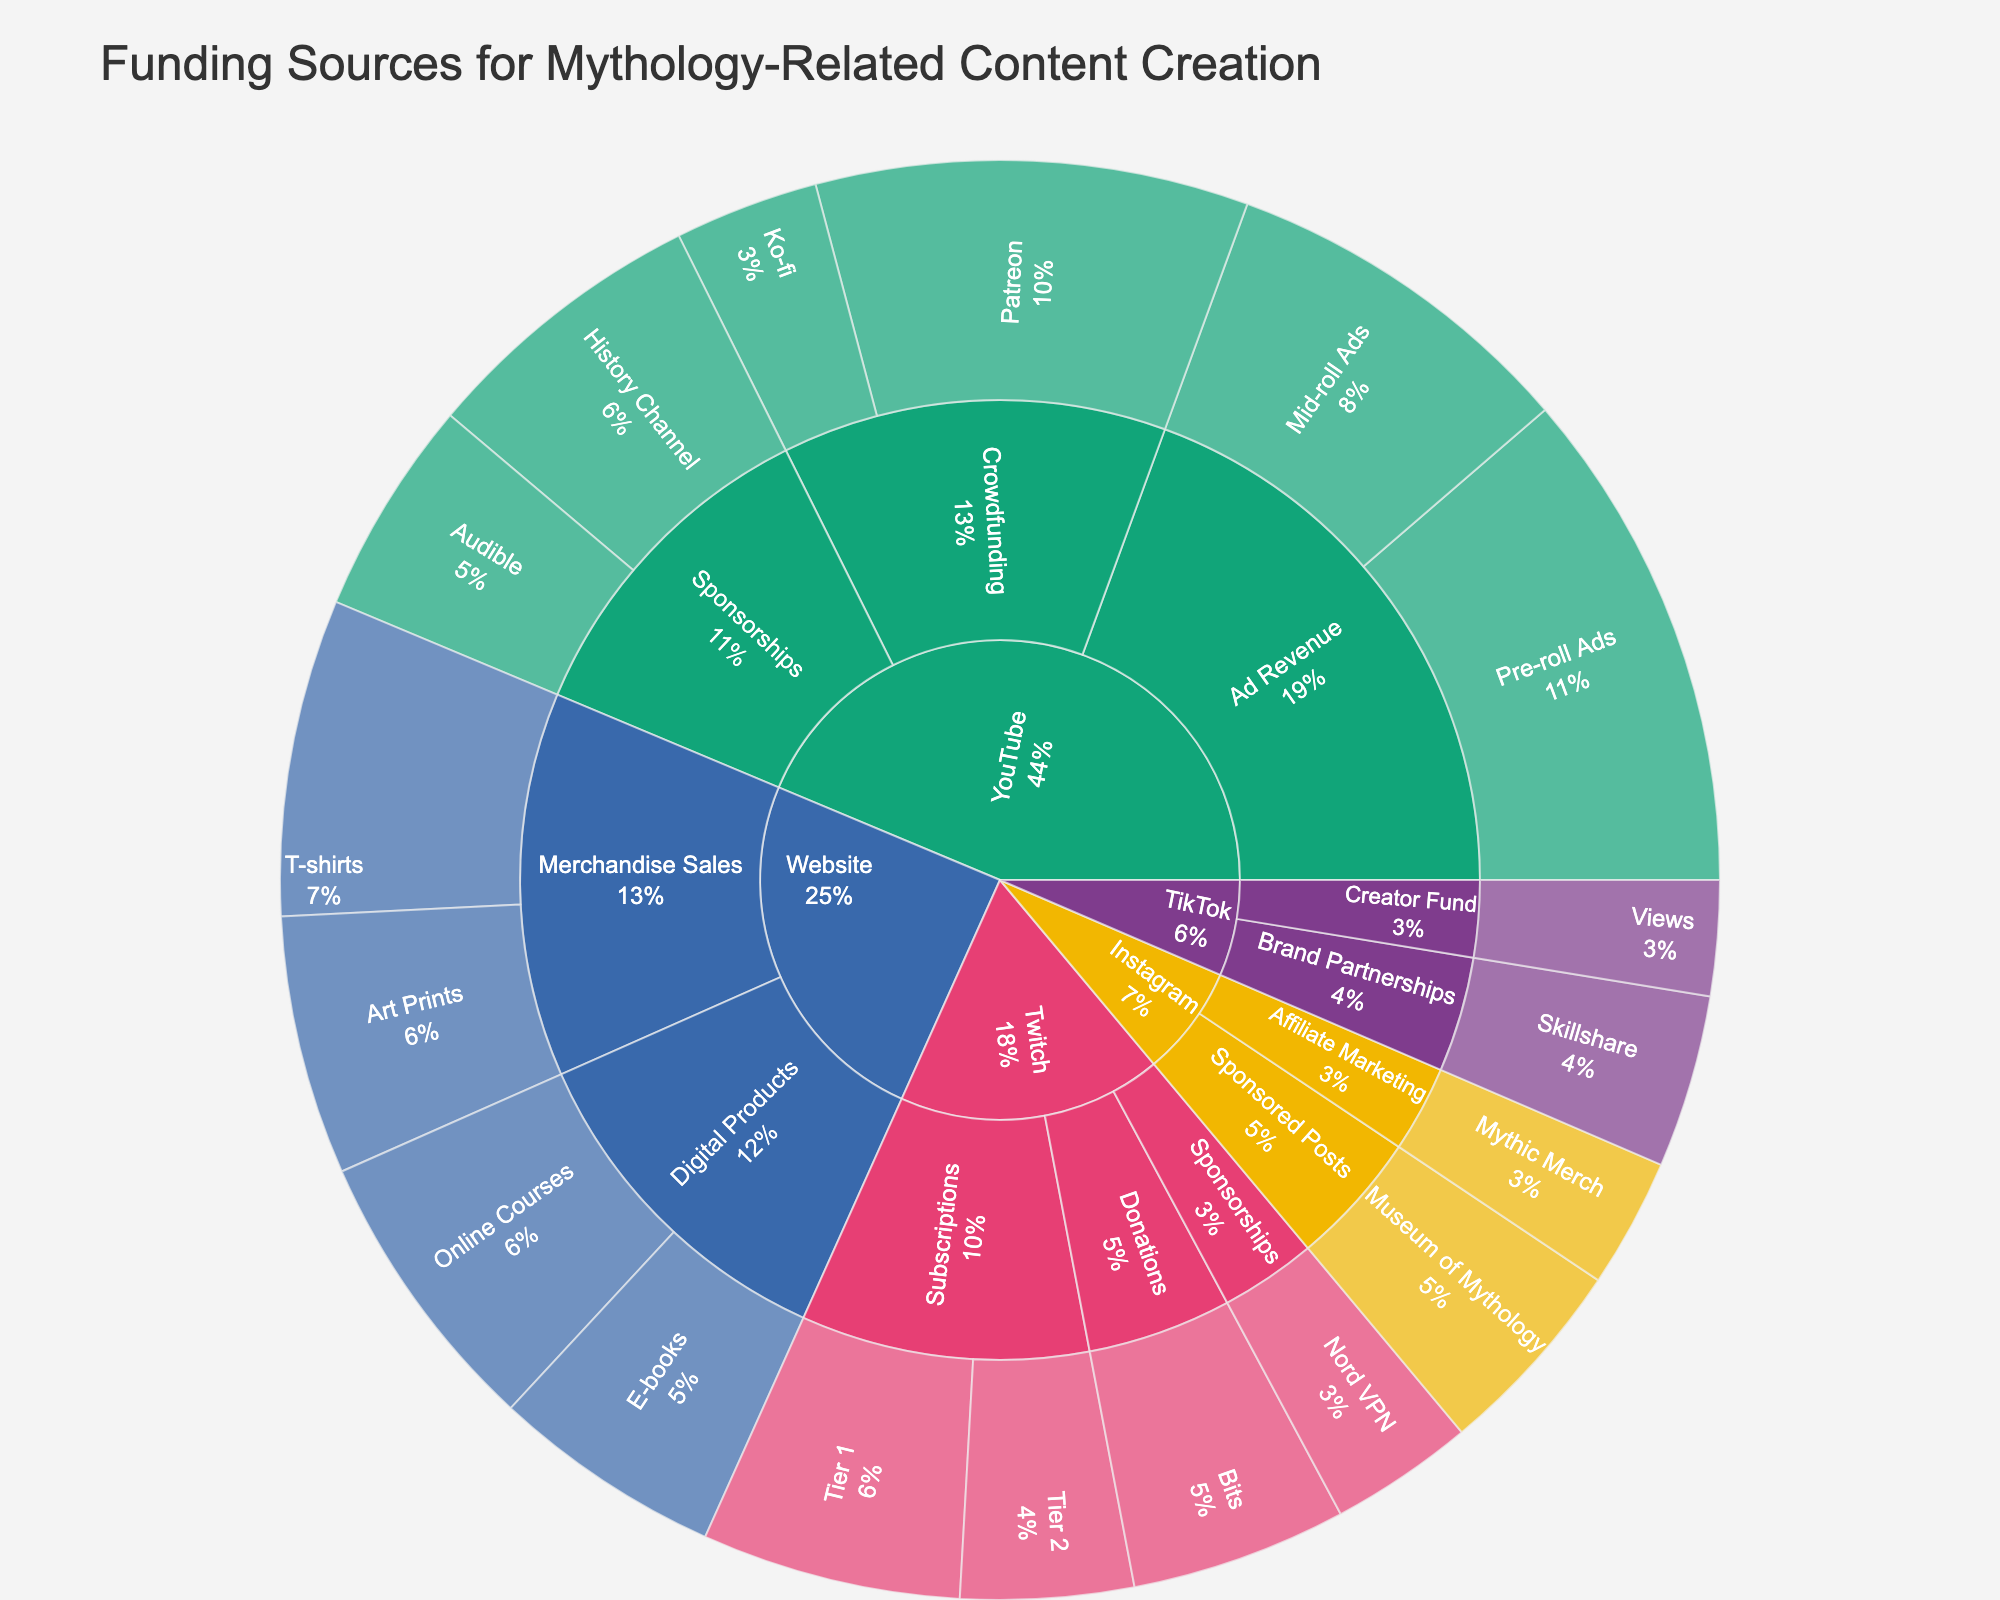What's the title of the Sunburst Plot? The title of the Sunburst Plot is located at the top of the figure, usually written in a larger font than the rest of the text on the plot.
Answer: Funding Sources for Mythology-Related Content Creation Which platform has the highest total funding? To find the platform with the highest total funding, compare the sum of values for each platform segment. YouTube has the largest segments and hence the highest total value, summing up all the YouTube sections.
Answer: YouTube What's the largest revenue source on YouTube? On YouTube, the largest revenue source can be identified by comparing the sizes of segments under YouTube. "Ad Revenue" is the largest, with segments for Pre-roll Ads (35) and Mid-roll Ads (25), totaling 60.
Answer: Ad Revenue What’s the combined value of Crowdfunding sources on YouTube? Add the values for Patreon (30) and Ko-fi (10) under YouTube’s Crowdfunding section. The combined value is 30 + 10 = 40.
Answer: 40 Which platform has sponsorship from Nord VPN? Look for the segment associated with Nord VPN. It is listed under Twitch in the Sponsorships section.
Answer: Twitch How much funding does TikTok get from Brand Partnerships? Check the segment under TikTok labeled "Brand Partnerships" and find the value associated with Skillshare, which is 12.
Answer: 12 Among Twitch and TikTok, which has higher funding from subscriptions, donations, and creator fund respectively combined? Add the values for subscriptions and donations for Twitch (Tier 1: 18, Tier 2: 12, Bits: 15) giving (18+12+15)=45 and add the creator fund for TikTok (Views: 8), so Twitch has higher combined funding.
Answer: Twitch What’s the total funding from YouTube’s Sponsorships? Add History Channel (20) and Audible (15) values under YouTube’s Sponsorships section. The total value is 20 + 15 = 35.
Answer: 35 Which platform has the least number of funding sources mentioned in the plot? Count the distinct funding sources for each platform. TikTok has only two funding sources—Creator Fund and Brand Partnerships—making it the platform with the least number of funding sources listed.
Answer: TikTok How does funding from donations on Twitch compare to ad revenue on YouTube? Compare the sum of donations on Twitch (Bits: 15) to the sum of ad revenue on YouTube (35 Pre-roll Ads + 25 Mid-roll Ads = 60). YouTube’s ad revenue is higher.
Answer: YouTube’s ad revenue is higher 